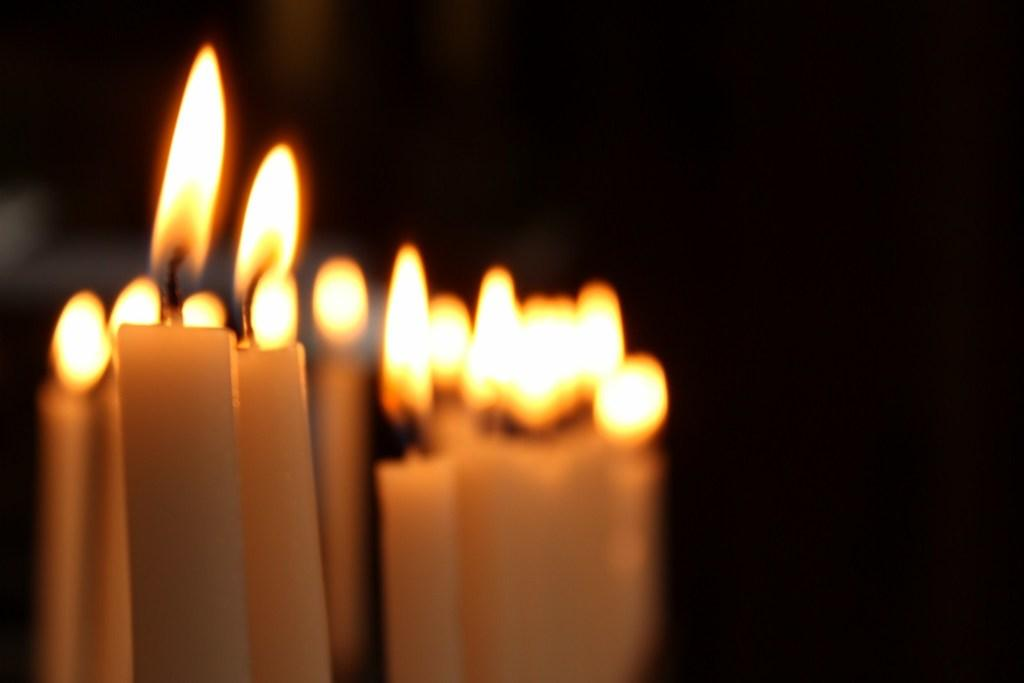What objects are present in the image that emit light? There are candles in the image that emit light. What is the source of light from the candles? The candles have fire, which is the source of light. What type of porter is responsible for carrying the candles in the image? There is no porter present in the image, and the candles are not being carried by anyone. 